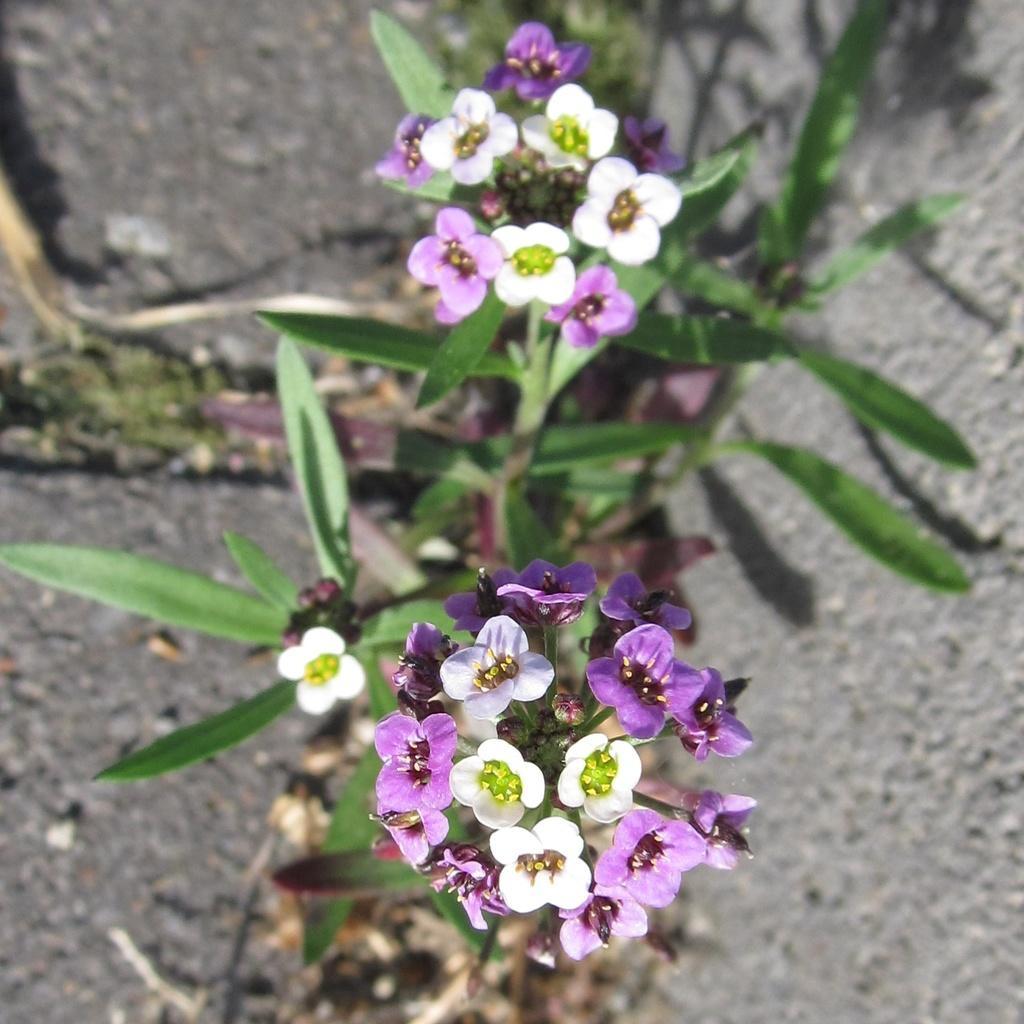How would you summarize this image in a sentence or two? There are white and violet color flowers of the plants which are having green color leaves. And the background is blurred. 